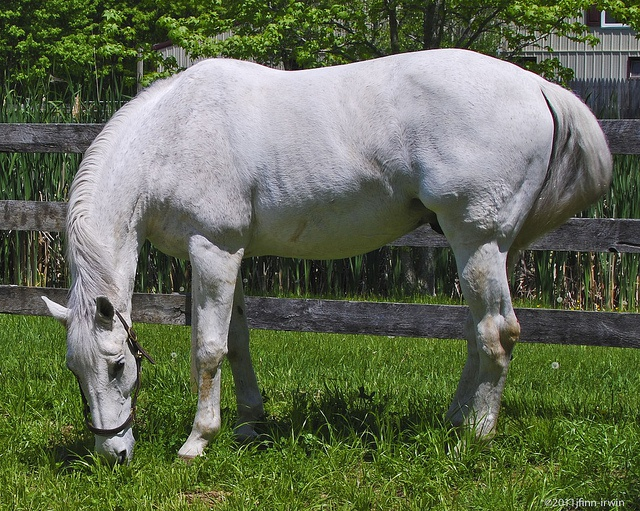Describe the objects in this image and their specific colors. I can see a horse in black, lightgray, darkgray, and gray tones in this image. 